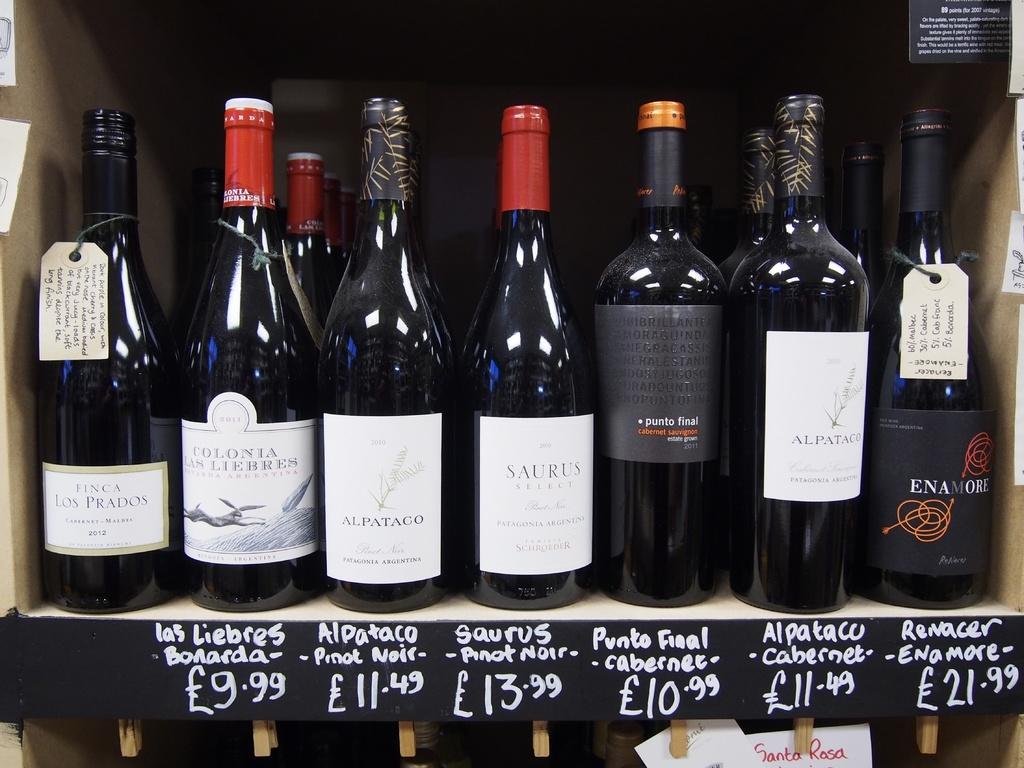What is the name of the "pinot noir" priced at £13.99?
Your answer should be compact. Saurus. What is the brand of pinot noir priced at $11.49?
Your answer should be very brief. Alpataco. 